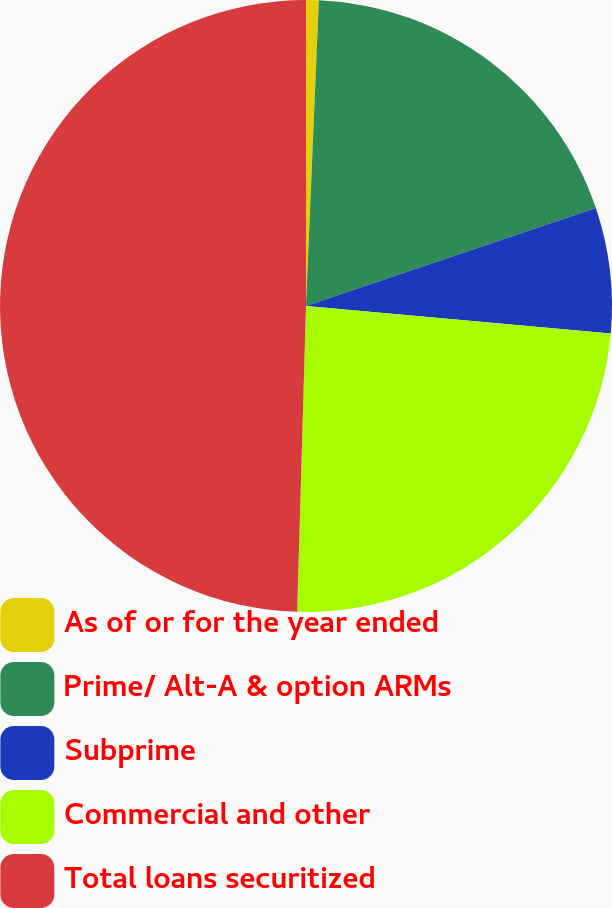Convert chart. <chart><loc_0><loc_0><loc_500><loc_500><pie_chart><fcel>As of or for the year ended<fcel>Prime/ Alt-A & option ARMs<fcel>Subprime<fcel>Commercial and other<fcel>Total loans securitized<nl><fcel>0.67%<fcel>19.14%<fcel>6.62%<fcel>24.03%<fcel>49.54%<nl></chart> 